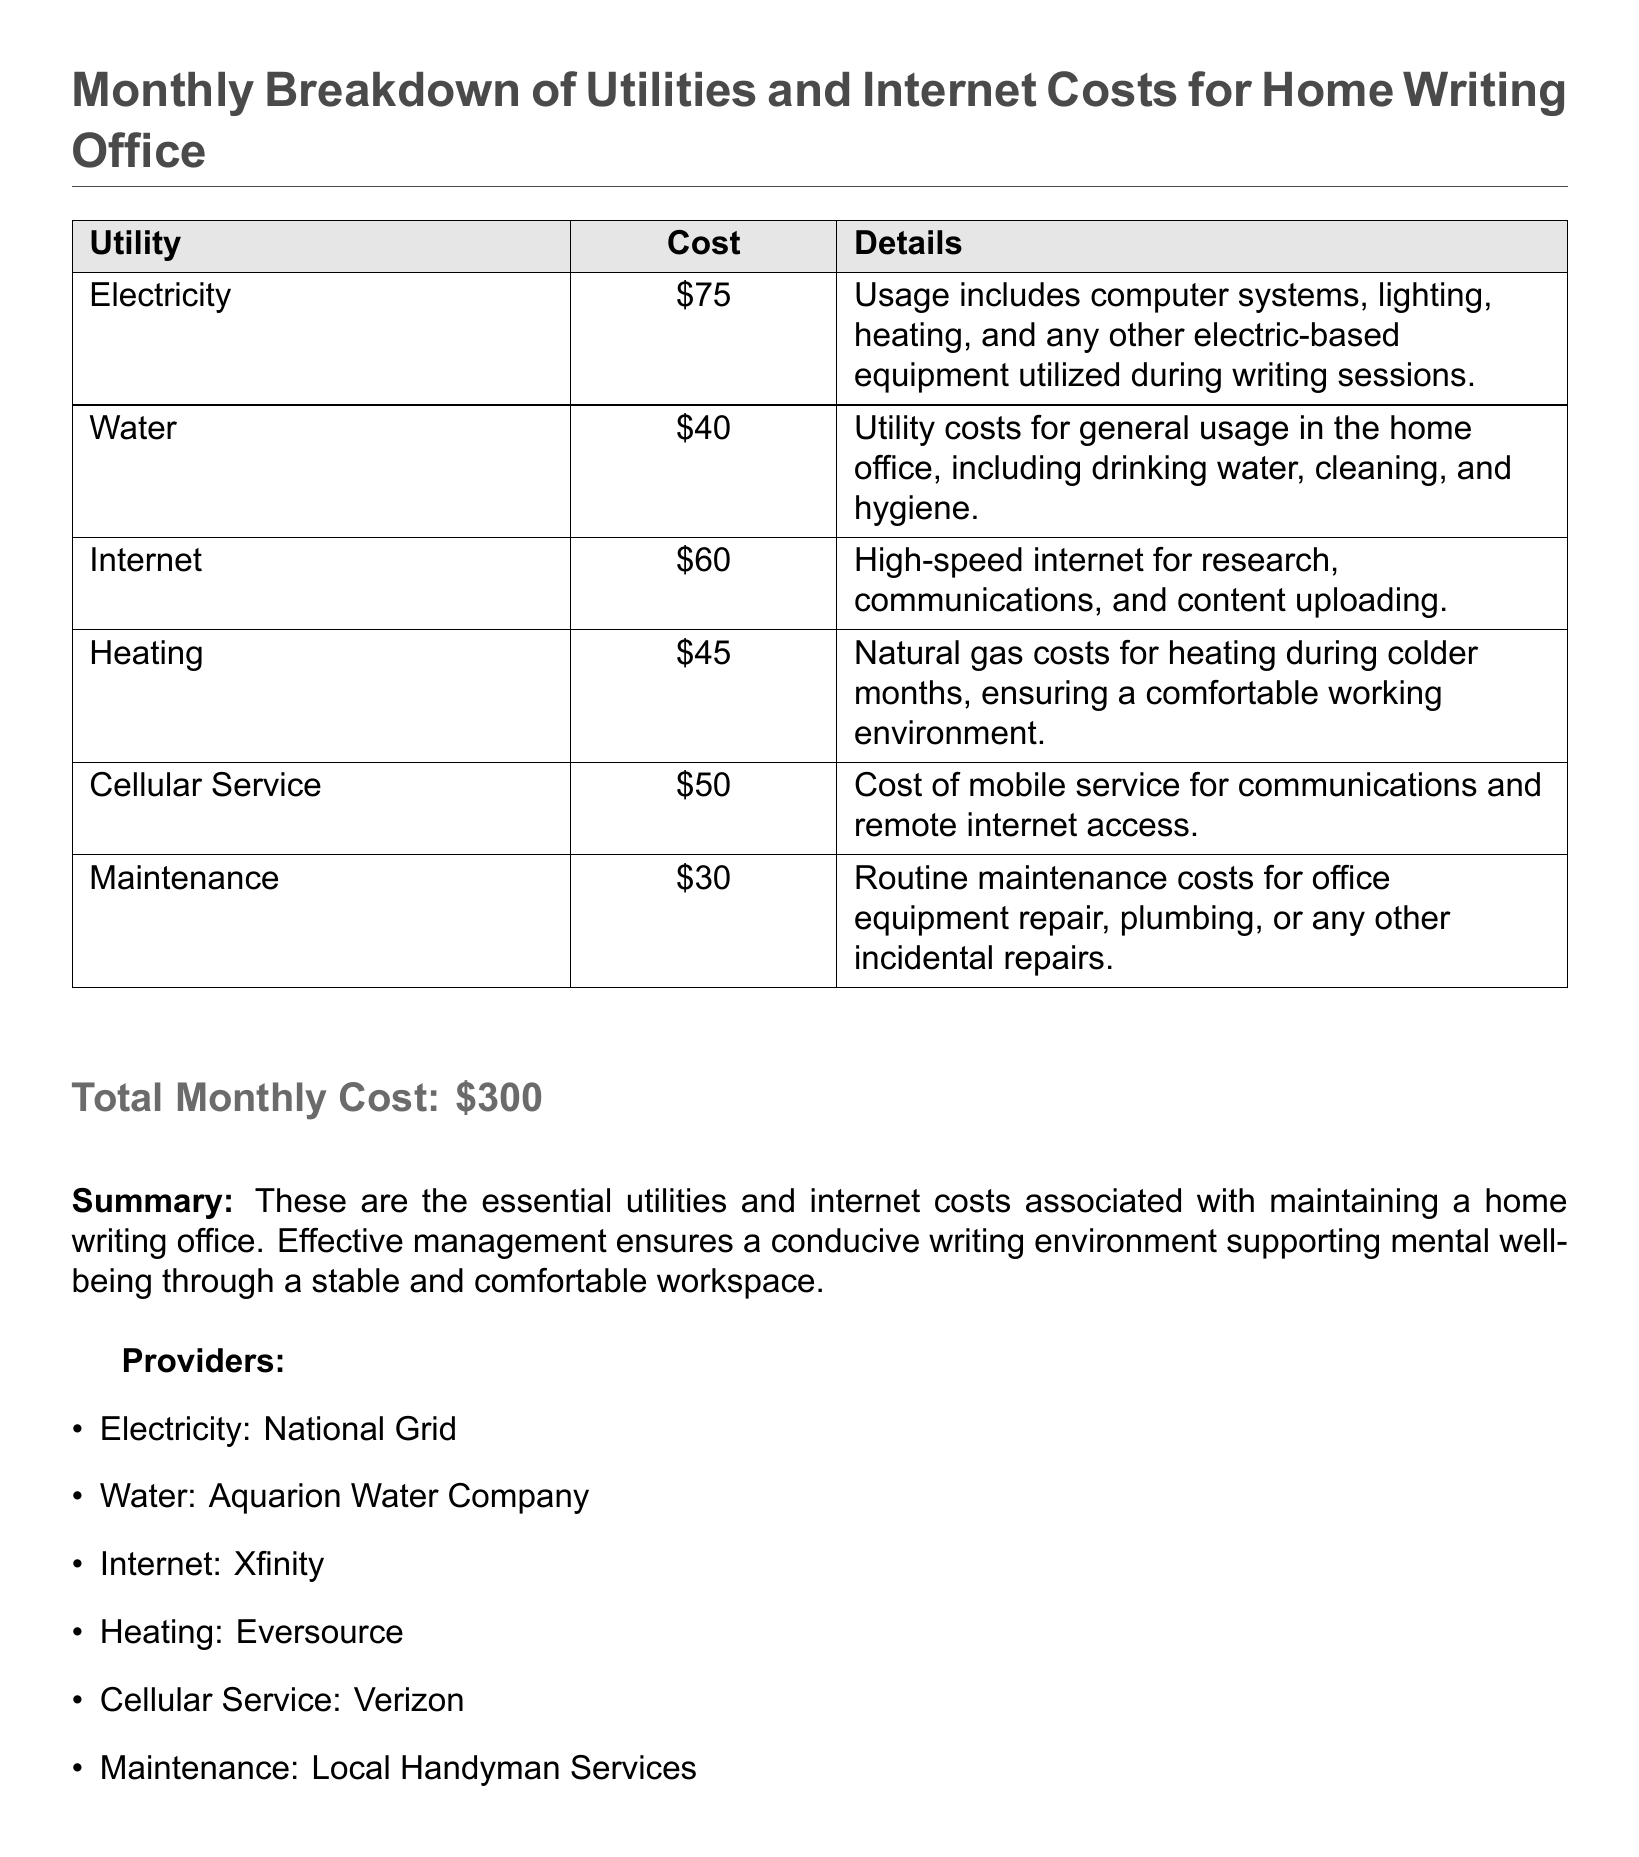What is the total monthly cost? The total monthly cost is explicitly stated in the document as the sum of all utility and internet costs.
Answer: $300 How much does electricity cost? The document lists the cost of electricity as part of the detailed cost breakdown.
Answer: $75 Which provider supplies internet? The document specifically names the provider responsible for internet services in the home office.
Answer: Xfinity What is the cost associated with heating? The document provides a clear cost for heating as part of the utility expenses.
Answer: $45 What details are included for the maintenance cost? The document mentions the nature of expenses included in the maintenance costs related to office upkeep.
Answer: Routine maintenance costs for office equipment repair, plumbing, or any other incidental repairs Why is a stable workspace important for mental well-being? The document offers a summary emphasizing the role of a comfortable writing environment in promoting mental well-being.
Answer: Effective management ensures a conducive writing environment supporting mental well-being Which utility is listed with the lowest cost? The document presents a comparative breakdown of costs, allowing for easy identification of the least expensive utility.
Answer: Maintenance How many types of utilities are mentioned in the report? The document lists distinct utilities and their costs, thus allowing for straightforward verification of the number of types discussed.
Answer: 6 